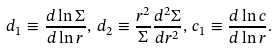Convert formula to latex. <formula><loc_0><loc_0><loc_500><loc_500>d _ { 1 } \equiv \frac { d \ln \Sigma } { d \ln r } , \, d _ { 2 } \equiv \frac { r ^ { 2 } } { \Sigma } \frac { d ^ { 2 } \Sigma } { d r ^ { 2 } } , \, c _ { 1 } \equiv \frac { d \ln c } { d \ln r } .</formula> 